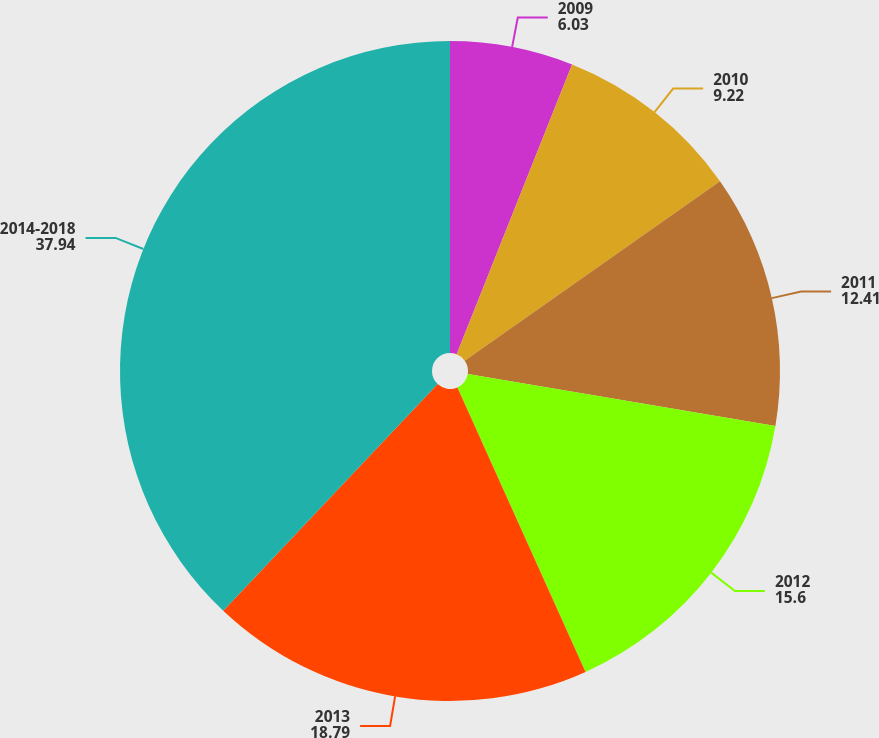Convert chart to OTSL. <chart><loc_0><loc_0><loc_500><loc_500><pie_chart><fcel>2009<fcel>2010<fcel>2011<fcel>2012<fcel>2013<fcel>2014-2018<nl><fcel>6.03%<fcel>9.22%<fcel>12.41%<fcel>15.6%<fcel>18.79%<fcel>37.94%<nl></chart> 